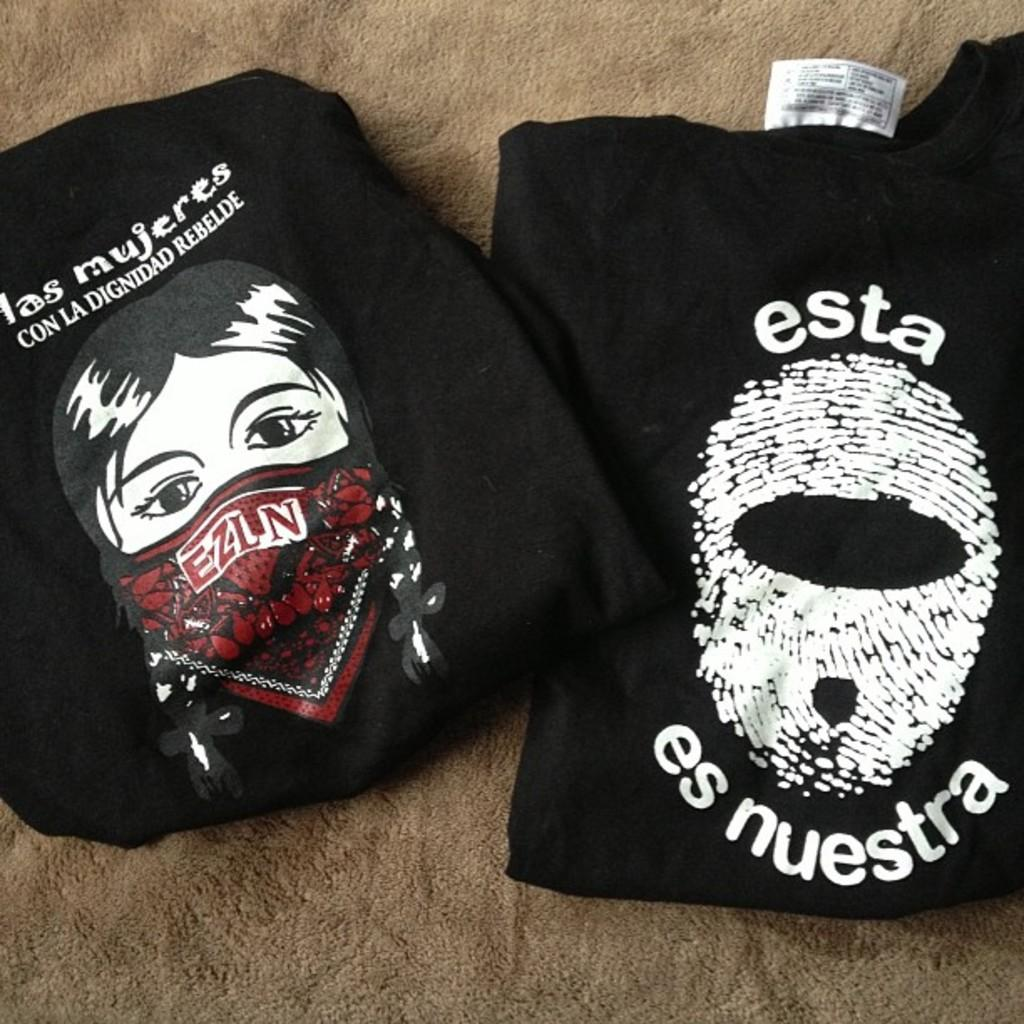What type of clothing is visible on the surface in the image? There are black t-shirts on the surface. What is featured on the t-shirts? There is writing and pictures on the t-shirts. Where is the duck located in the image? There is no duck present in the image. What type of hall can be seen in the image? There is no hall present in the image. 